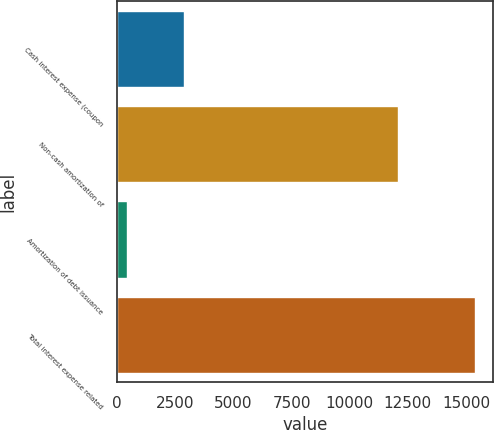Convert chart. <chart><loc_0><loc_0><loc_500><loc_500><bar_chart><fcel>Cash interest expense (coupon<fcel>Non-cash amortization of<fcel>Amortization of debt issuance<fcel>Total interest expense related<nl><fcel>2875<fcel>12085<fcel>443<fcel>15403<nl></chart> 